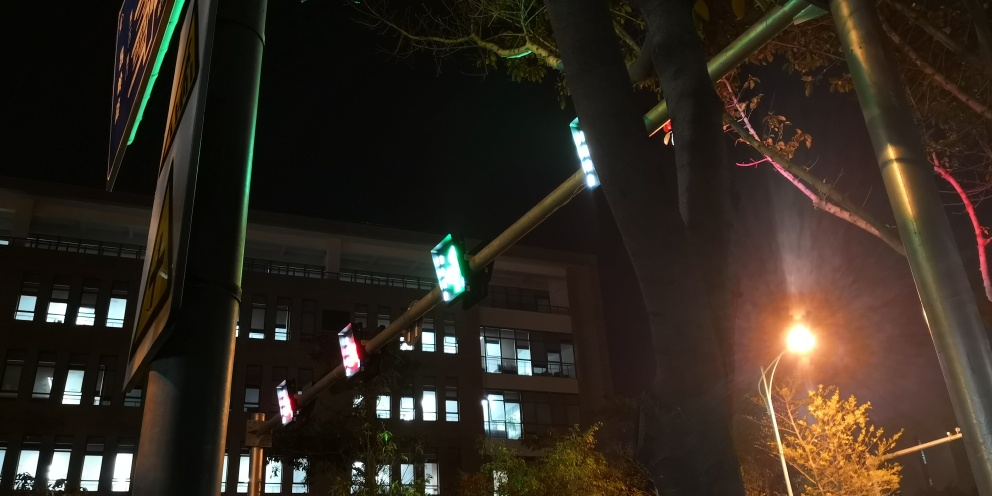Are the colors in the image vibrant? The colors in the image possess moderate vibrancy, mostly deriving from the artificial lights such as the green of the traffic signal and scattered reflections off the building. However, the overall illumination is dim since the photo is taken at night, which mutes the vibrancy that would otherwise be more apparent in a daylight setting. 